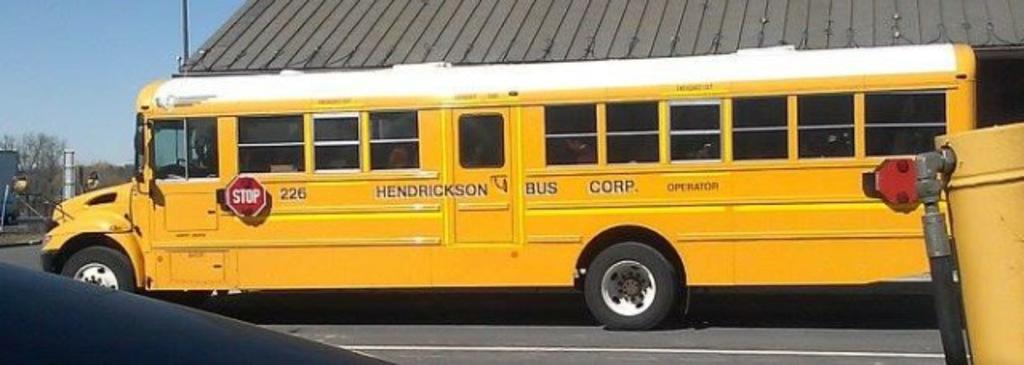What does the red sign tell you to do when it is open?
Offer a very short reply. Stop. What bus number is this?
Ensure brevity in your answer.  226. 